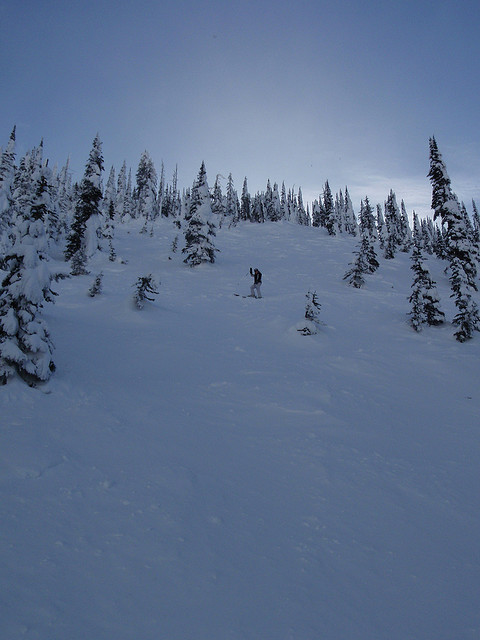Can you discuss the potential challenges posed by the snow-covered terrain for winter sports enthusiasts like snowboarders and skiers? The enthralling yet challenging snow-covered terrain provides a playground for winter sports but also harbors potential risks such as limited visibility, hidden tree wells, and uneven surfaces concealed under the snow. Skiers and snowboarders must navigate these obstacles with caution, balancing their love for adventure with safety considerations. Awareness and preparedness for possible avalanches in such mountainous terrains are also paramount for ensuring a safe and enjoyable experience. 